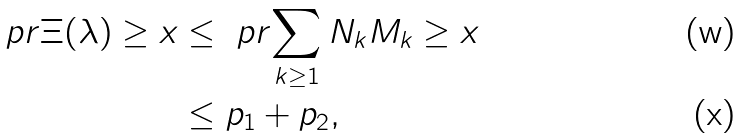Convert formula to latex. <formula><loc_0><loc_0><loc_500><loc_500>\ p r { \Xi ( \lambda ) \geq x } & \leq \ p r { \sum _ { k \geq 1 } N _ { k } M _ { k } \geq x } \\ & \leq p _ { 1 } + p _ { 2 } ,</formula> 